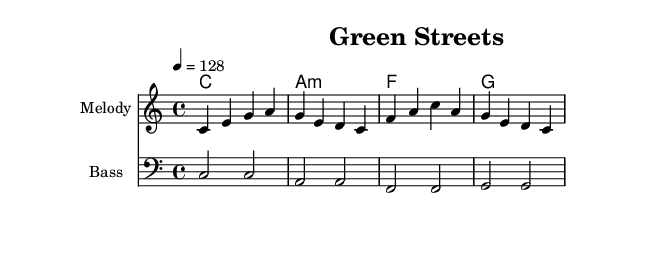What is the key signature of this music? The key signature is C major, which has no sharps or flats.
Answer: C major What is the time signature of this music? The time signature is indicated as 4/4, meaning there are four beats in each measure.
Answer: 4/4 What is the tempo marking of this music? The tempo marking is indicated as 4 = 128, meaning the quarter note receives a tempo of 128 beats per minute.
Answer: 128 How many measures are in the melody? The melody has four measures as shown in the notation, with distinct rhythmic patterns for each.
Answer: 4 What is the first chord in the harmonic progression? The first chord shown in the harmonic progression is C major, noted at the beginning of the chord line.
Answer: C How does the bass line relate to the melody? The bass line provides a foundation for the melody, moving in parallel motion primarily in sync with the harmonic roots.
Answer: Foundation What is the theme of the lyrics? The lyrics emphasize walking and enjoying green streets, promoting environmental consciousness and active transportation.
Answer: Environmental stewardship 